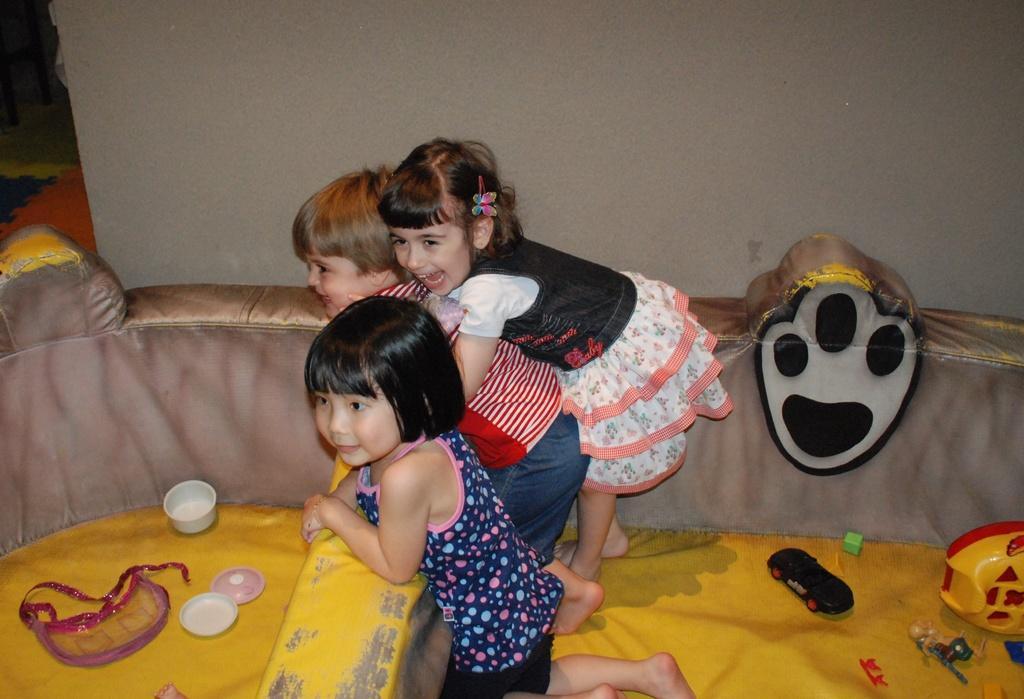How would you summarize this image in a sentence or two? In this image I can see group of people. In front the person is wearing blue and black color dress. I can also see few toys on the yellow color cloth, background the wall is in cream color. 